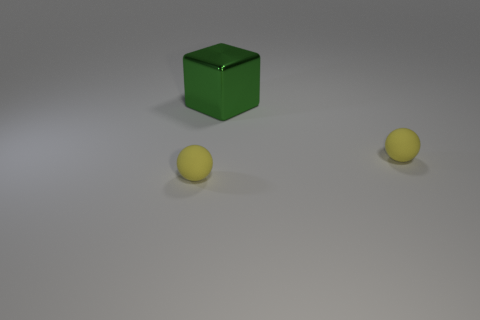Is the color of the object to the right of the shiny cube the same as the thing to the left of the metal cube?
Your answer should be very brief. Yes. How many green things are either big metallic objects or rubber objects?
Your answer should be very brief. 1. Are there any yellow spheres that are right of the thing that is behind the thing that is on the right side of the green metal block?
Make the answer very short. Yes. Are there fewer green metal objects than tiny yellow things?
Offer a very short reply. Yes. Are there any large gray cylinders?
Provide a short and direct response. No. What is the color of the small sphere behind the yellow object in front of the thing on the right side of the large green metallic object?
Offer a terse response. Yellow. Is there another big block that has the same color as the big metal cube?
Your response must be concise. No. There is a yellow object on the left side of the large green block; what is its shape?
Your answer should be very brief. Sphere. What is the color of the big metal thing?
Provide a succinct answer. Green. What number of big shiny blocks are on the right side of the big green shiny block?
Offer a very short reply. 0. 